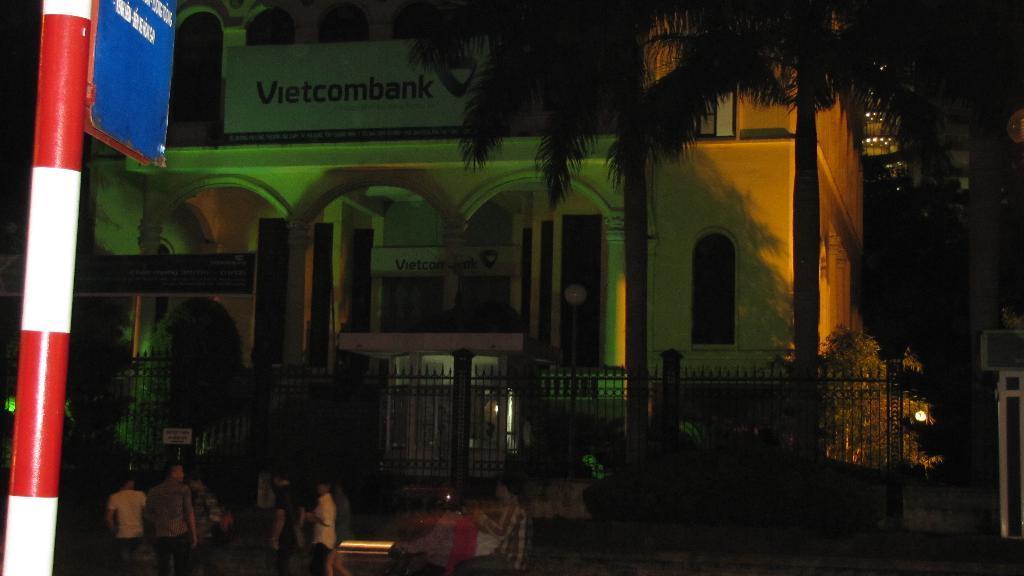In one or two sentences, can you explain what this image depicts? In this image, there are trees in front of the building. There is a fencing and some persons at the bottom of the image. There is a sign board on the left side of the image. 